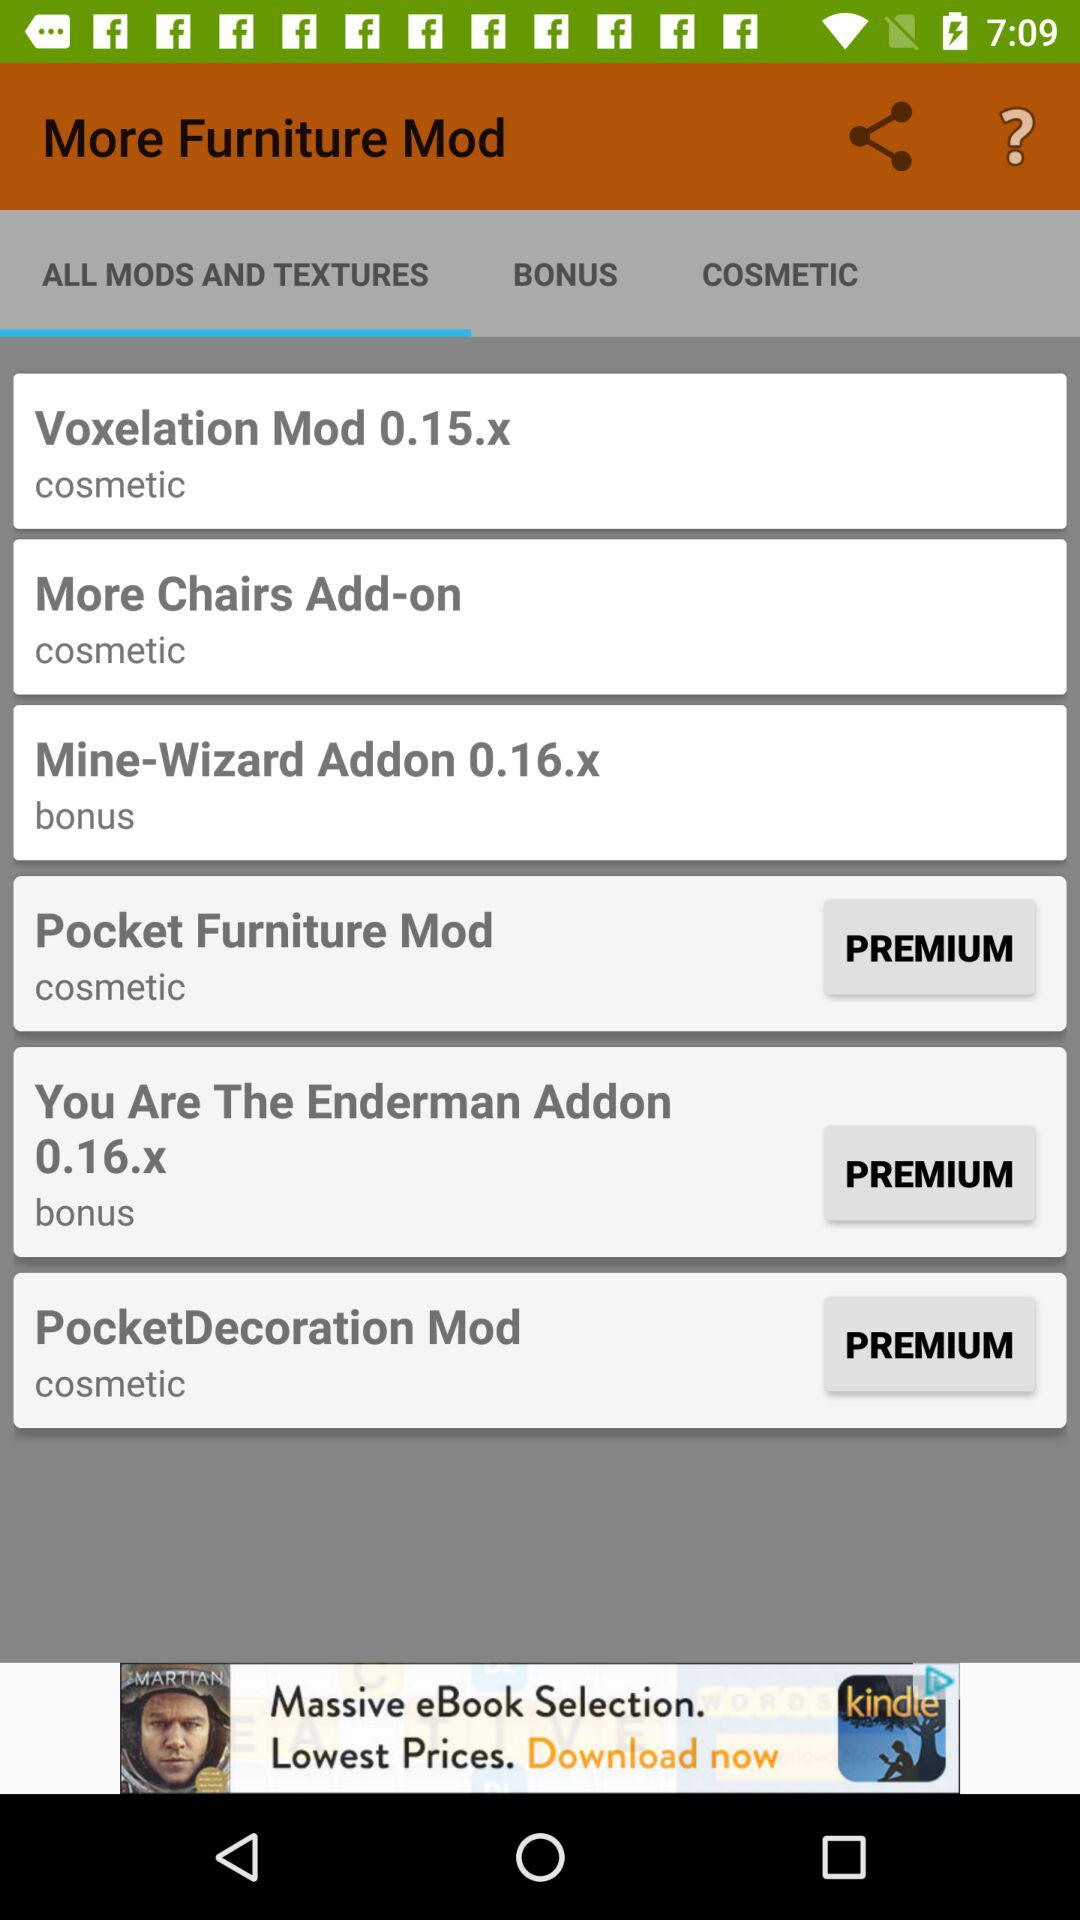What is the texture of "Voxelation Mod 0.15.x"? The texture is "cosmetic". 